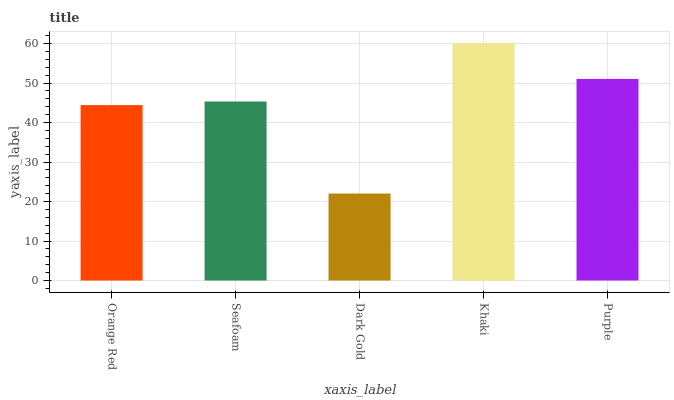Is Dark Gold the minimum?
Answer yes or no. Yes. Is Khaki the maximum?
Answer yes or no. Yes. Is Seafoam the minimum?
Answer yes or no. No. Is Seafoam the maximum?
Answer yes or no. No. Is Seafoam greater than Orange Red?
Answer yes or no. Yes. Is Orange Red less than Seafoam?
Answer yes or no. Yes. Is Orange Red greater than Seafoam?
Answer yes or no. No. Is Seafoam less than Orange Red?
Answer yes or no. No. Is Seafoam the high median?
Answer yes or no. Yes. Is Seafoam the low median?
Answer yes or no. Yes. Is Dark Gold the high median?
Answer yes or no. No. Is Dark Gold the low median?
Answer yes or no. No. 